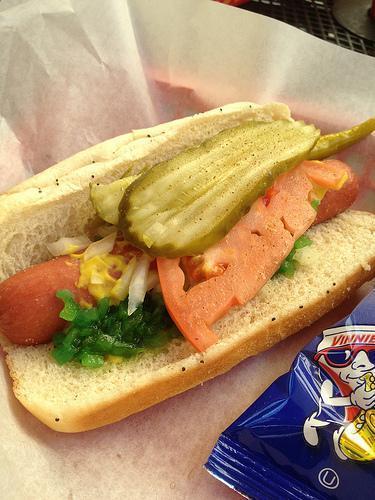How many pickles are on the hot dog?
Give a very brief answer. 2. How many hot dogs are in the picture?
Give a very brief answer. 1. 